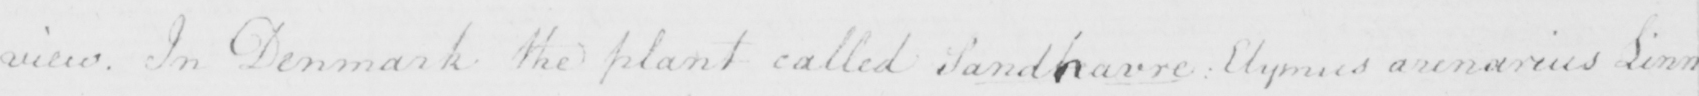What is written in this line of handwriting? view . In Denmark the plant called Sandharre :  Elymus arenarius Linn . 